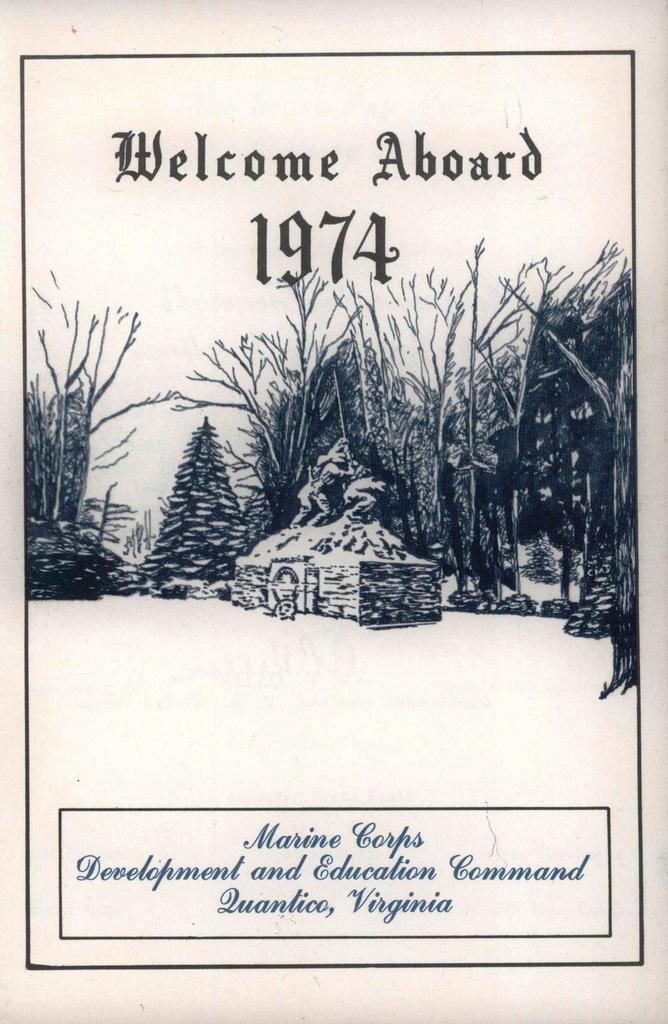Describe this image in one or two sentences. This is a poster. On the poster there are trees and there is a statue. At the top there is a text and there are numbers. At the bottom there is a text. 